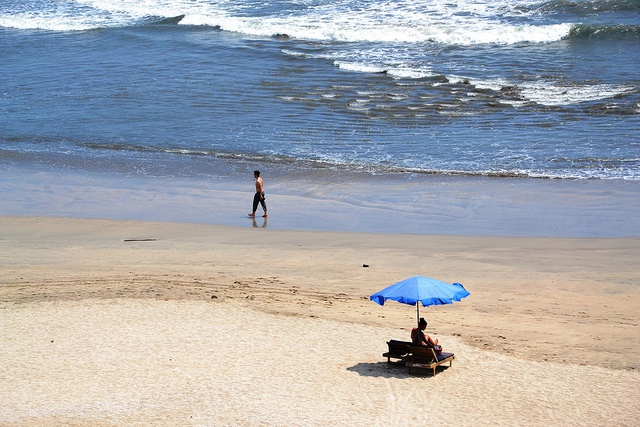Describe the objects in this image and their specific colors. I can see umbrella in gray, lightblue, and blue tones, chair in gray, black, navy, and maroon tones, people in gray, black, maroon, and darkgray tones, chair in gray, black, darkgray, and darkgreen tones, and people in gray, black, maroon, tan, and brown tones in this image. 